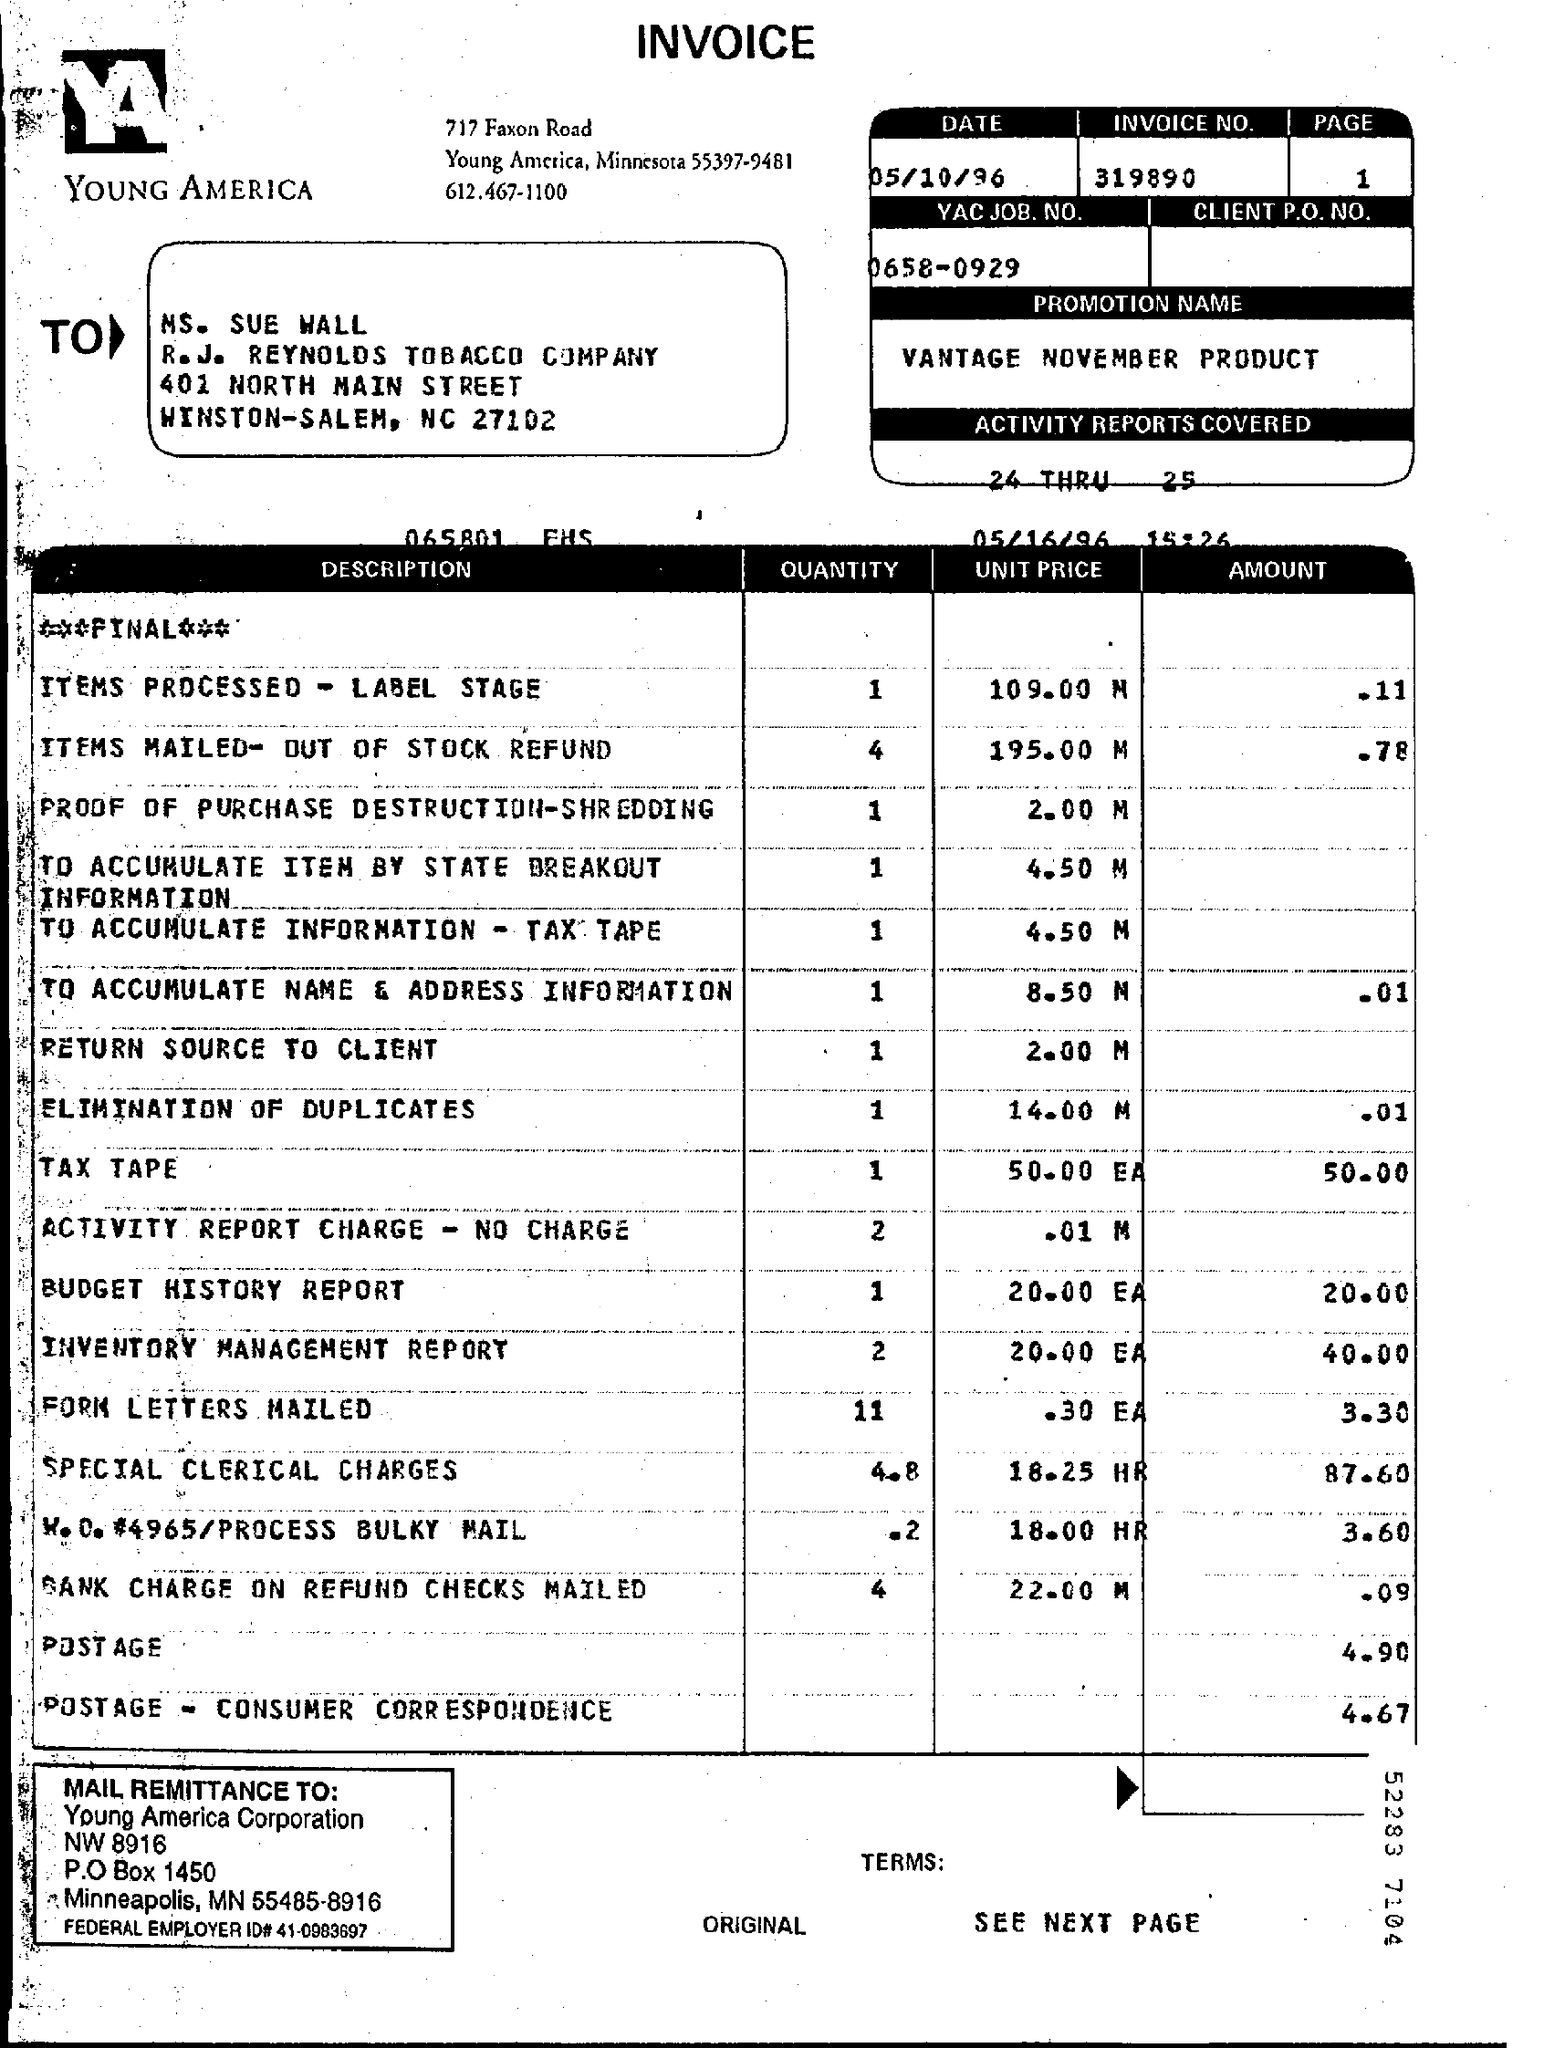What is the Invoice No.?
Ensure brevity in your answer.  319890. What is the YAC JOB NO.?
Your answer should be compact. 0658-0929. What is the Promotion Name?
Give a very brief answer. Vantage November Product. 